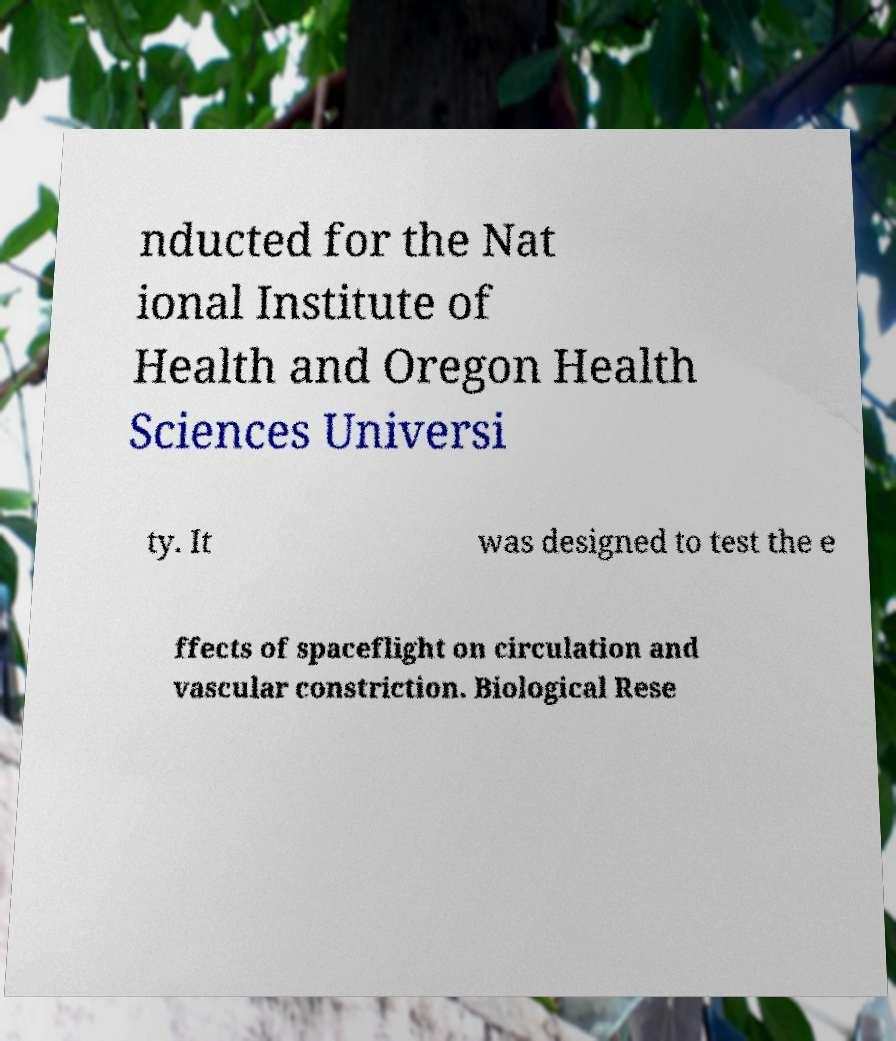I need the written content from this picture converted into text. Can you do that? nducted for the Nat ional Institute of Health and Oregon Health Sciences Universi ty. It was designed to test the e ffects of spaceflight on circulation and vascular constriction. Biological Rese 